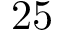Convert formula to latex. <formula><loc_0><loc_0><loc_500><loc_500>2 5</formula> 